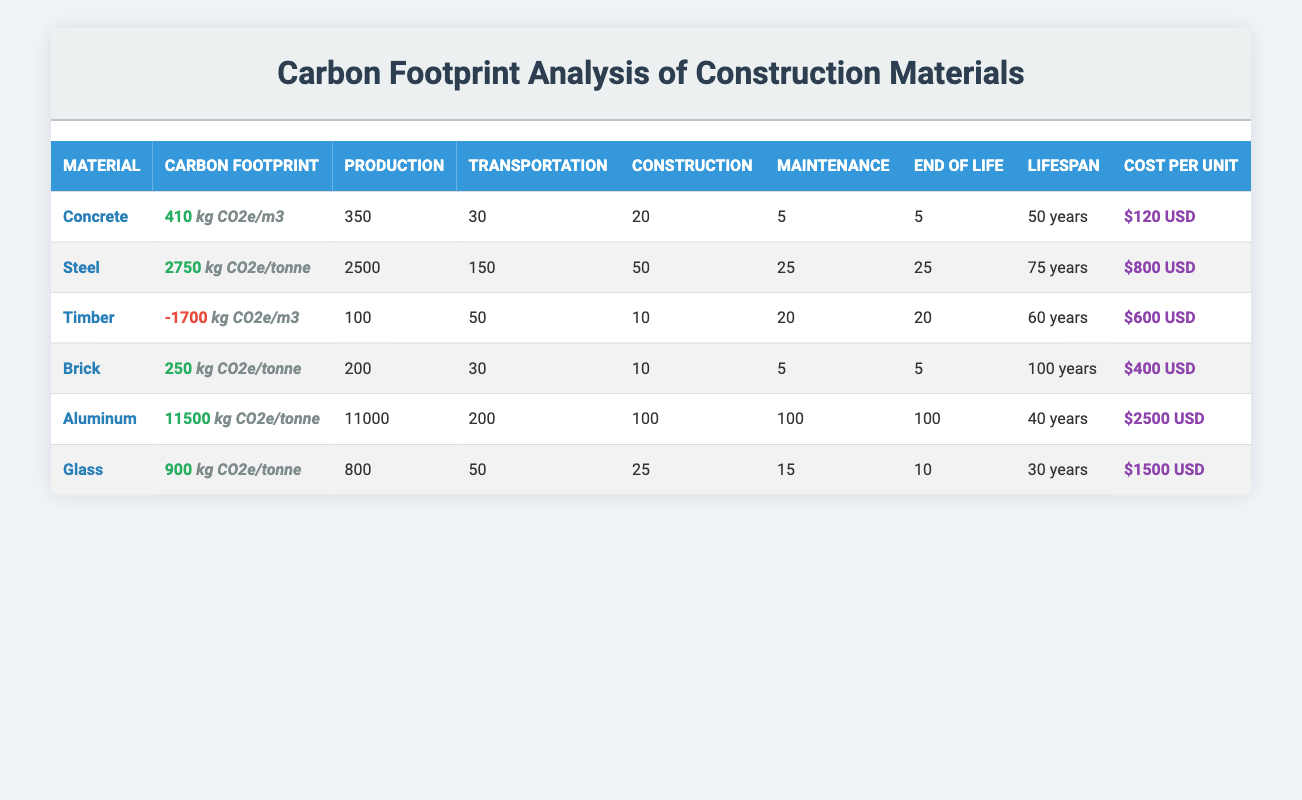What is the carbon footprint of Concrete? In the table, under the "Carbon Footprint" column for Concrete, the value listed is 410 kg CO2e/m3.
Answer: 410 kg CO2e/m3 Which material has the highest production emissions? Looking at the "Production" column, Steel has the highest production emissions at 2500 kg CO2e/tonne, as compared to the other materials listed.
Answer: Steel Is the carbon footprint of Timber positive? Timber has a carbon footprint of -1700 kg CO2e/m3, which is a negative value, indicating that it absorbs more carbon than it emits. Therefore, it's not positive.
Answer: No What is the average cost per unit of all materials listed? To find the average cost per unit, sum all costs: (120 + 800 + 600 + 400 + 2500 + 1500) = 5020. There are 6 materials, so the average cost = 5020 / 6 = 836.67.
Answer: 836.67 USD Does Glass have a longer lifespan than Concrete? Concrete has a lifespan of 50 years, while Glass has a lifespan of 30 years. Since 50 is greater than 30, Glass does not have a longer lifespan than Concrete.
Answer: No What is the total carbon footprint of Steel and Aluminum combined? The carbon footprints are 2750 kg CO2e/tonne for Steel and 11500 kg CO2e/tonne for Aluminum. Adding them together gives: 2750 + 11500 = 14250 kg CO2e/tonne.
Answer: 14250 kg CO2e/tonne Is Timber less carbon-intensive than Brick? Timber has a carbon footprint of -1700 kg CO2e/m3, while Brick has a footprint of 250 kg CO2e/tonne. Since -1700 is far less than 250, Timber is less carbon-intensive than Brick.
Answer: Yes What is the difference in lifespan between the shortest and longest lifespan materials? The shortest lifespan is Glass at 30 years and the longest is Brick at 100 years. The difference is 100 - 30 = 70 years.
Answer: 70 years How much lower is the carbon footprint of Aluminum compared to Steel? Aluminum has a carbon footprint of 11500 kg CO2e/tonne and Steel has 2750 kg CO2e/tonne. To find the difference: 11500 - 2750 = 8750.
Answer: 8750 kg CO2e/tonne 